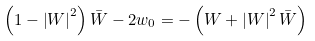<formula> <loc_0><loc_0><loc_500><loc_500>\left ( 1 - \left | W \right | ^ { 2 } \right ) \bar { W } - 2 w _ { 0 } = - \left ( W + \left | W \right | ^ { 2 } \bar { W } \right )</formula> 